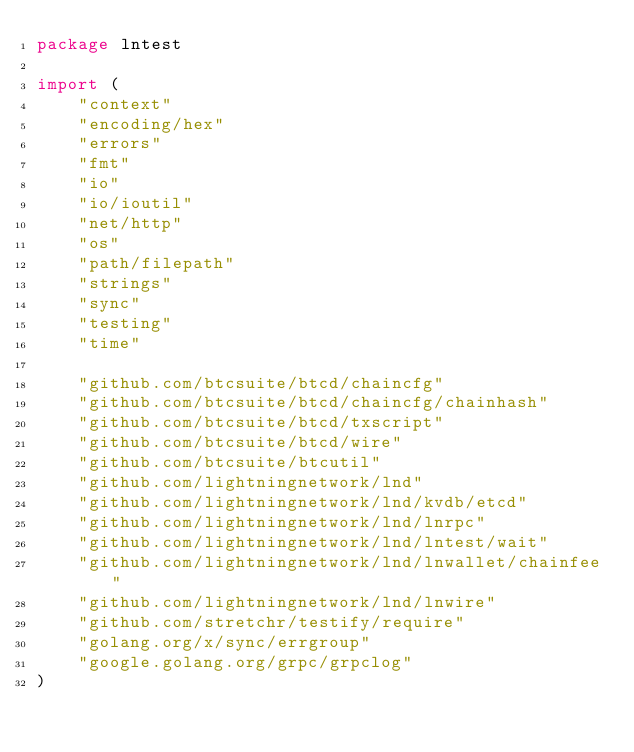Convert code to text. <code><loc_0><loc_0><loc_500><loc_500><_Go_>package lntest

import (
	"context"
	"encoding/hex"
	"errors"
	"fmt"
	"io"
	"io/ioutil"
	"net/http"
	"os"
	"path/filepath"
	"strings"
	"sync"
	"testing"
	"time"

	"github.com/btcsuite/btcd/chaincfg"
	"github.com/btcsuite/btcd/chaincfg/chainhash"
	"github.com/btcsuite/btcd/txscript"
	"github.com/btcsuite/btcd/wire"
	"github.com/btcsuite/btcutil"
	"github.com/lightningnetwork/lnd"
	"github.com/lightningnetwork/lnd/kvdb/etcd"
	"github.com/lightningnetwork/lnd/lnrpc"
	"github.com/lightningnetwork/lnd/lntest/wait"
	"github.com/lightningnetwork/lnd/lnwallet/chainfee"
	"github.com/lightningnetwork/lnd/lnwire"
	"github.com/stretchr/testify/require"
	"golang.org/x/sync/errgroup"
	"google.golang.org/grpc/grpclog"
)
</code> 